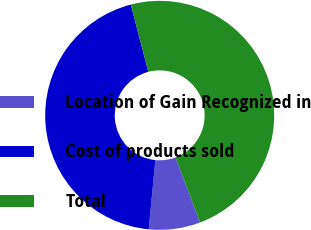<chart> <loc_0><loc_0><loc_500><loc_500><pie_chart><fcel>Location of Gain Recognized in<fcel>Cost of products sold<fcel>Total<nl><fcel>7.27%<fcel>44.41%<fcel>48.33%<nl></chart> 